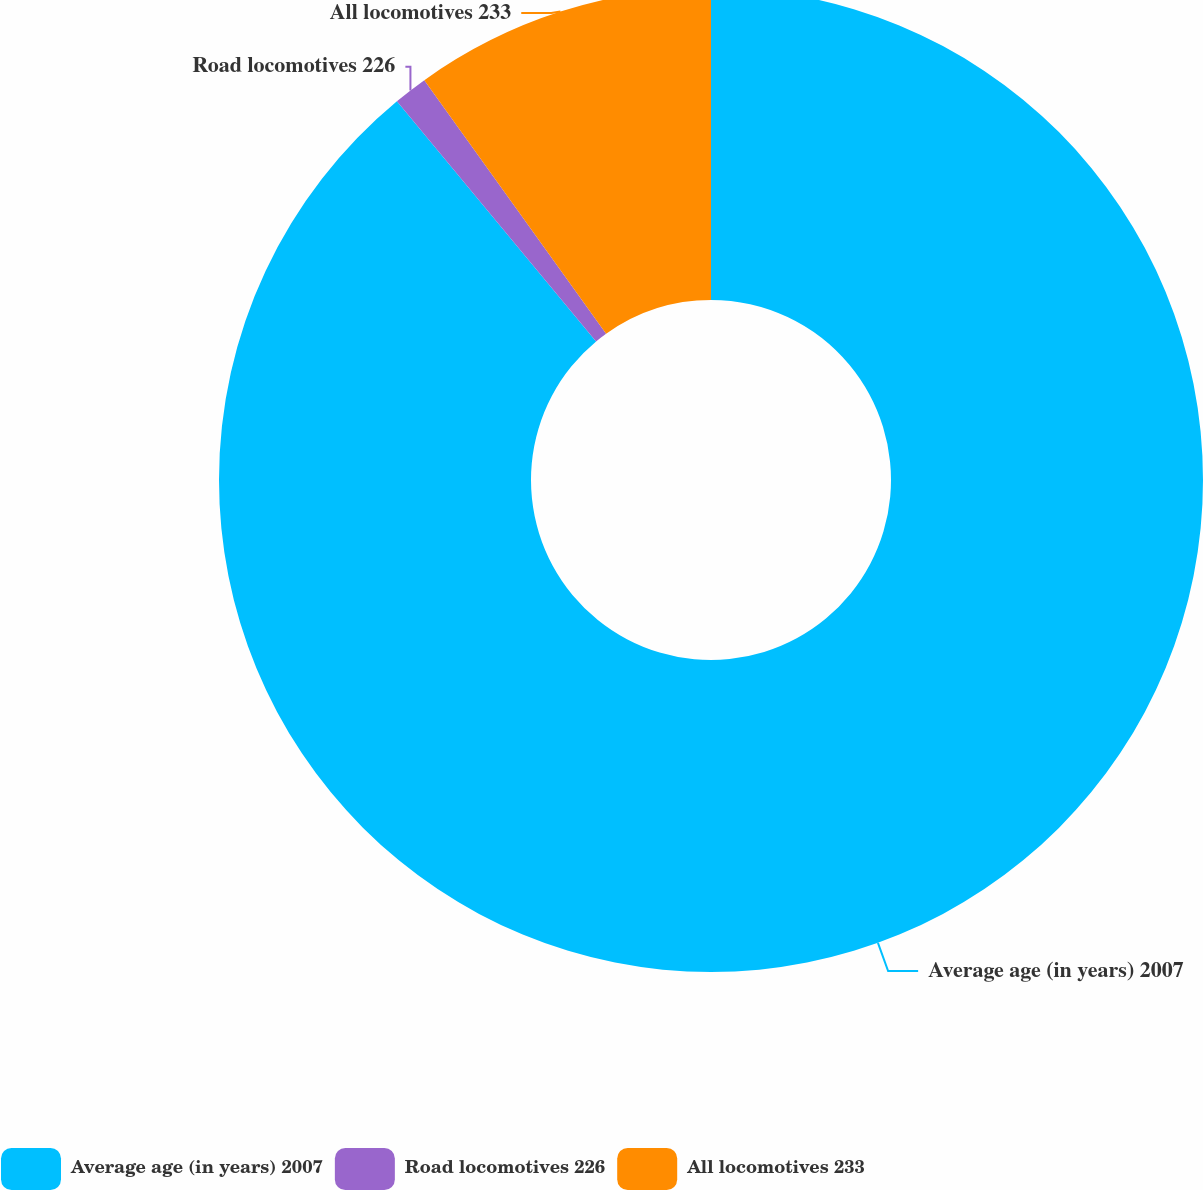<chart> <loc_0><loc_0><loc_500><loc_500><pie_chart><fcel>Average age (in years) 2007<fcel>Road locomotives 226<fcel>All locomotives 233<nl><fcel>88.98%<fcel>1.12%<fcel>9.9%<nl></chart> 